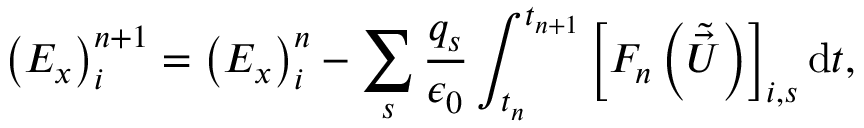Convert formula to latex. <formula><loc_0><loc_0><loc_500><loc_500>\left ( E _ { x } \right ) _ { i } ^ { n + 1 } = \left ( E _ { x } \right ) _ { i } ^ { n } - \sum _ { s } \frac { q _ { s } } { \epsilon _ { 0 } } \int _ { t _ { n } } ^ { t _ { n + 1 } } \left [ F _ { n } \left ( \tilde { \vec { U } } \right ) \right ] _ { i , s } d t ,</formula> 